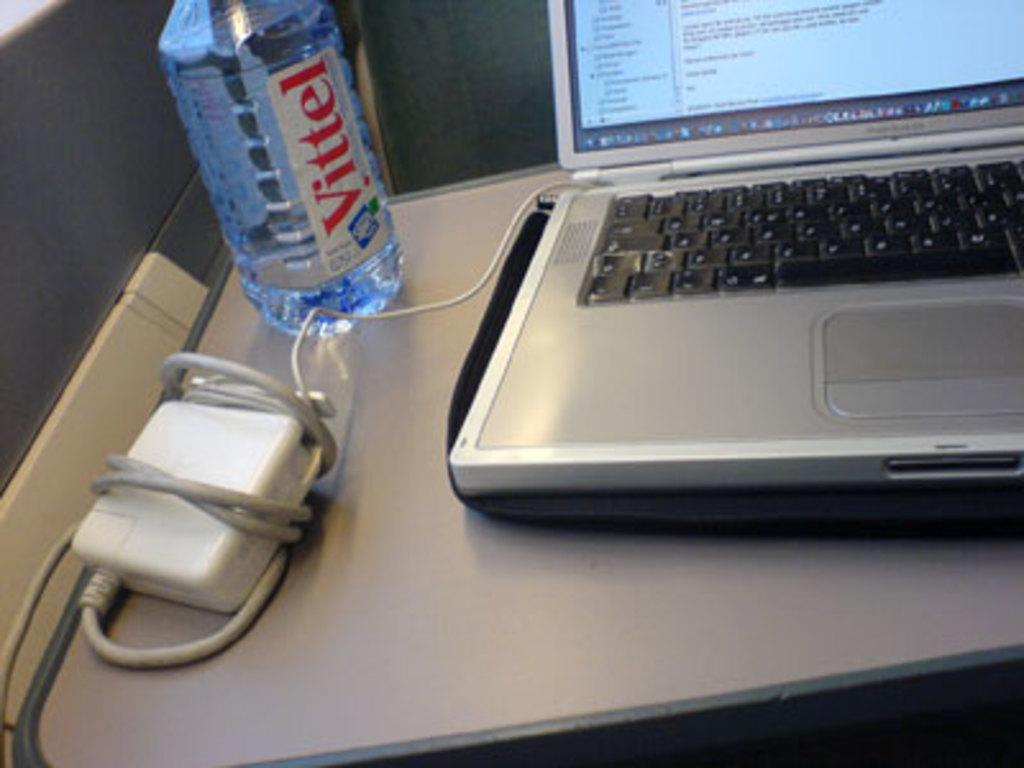<image>
Render a clear and concise summary of the photo. Bottle of Vitel water next to a laptop and power cord. 